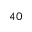<formula> <loc_0><loc_0><loc_500><loc_500>^ { 4 0 }</formula> 